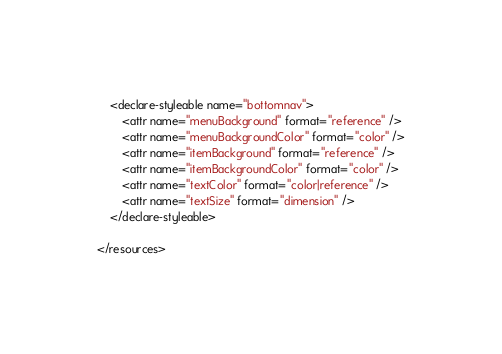Convert code to text. <code><loc_0><loc_0><loc_500><loc_500><_XML_>
    <declare-styleable name="bottomnav">
        <attr name="menuBackground" format="reference" />
        <attr name="menuBackgroundColor" format="color" />
        <attr name="itemBackground" format="reference" />
        <attr name="itemBackgroundColor" format="color" />
        <attr name="textColor" format="color|reference" />
        <attr name="textSize" format="dimension" />
    </declare-styleable>

</resources></code> 